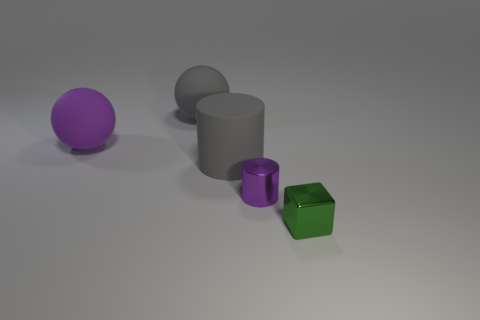Does the gray ball have the same material as the tiny thing that is right of the purple metallic object?
Keep it short and to the point. No. There is a cube that is the same material as the small purple thing; what is its size?
Offer a terse response. Small. Is there a large gray matte thing of the same shape as the tiny purple thing?
Your response must be concise. Yes. How many objects are either things that are to the right of the purple shiny thing or big purple things?
Your answer should be compact. 2. There is a matte sphere that is the same color as the large cylinder; what is its size?
Your answer should be very brief. Large. Does the ball in front of the gray ball have the same color as the tiny object that is left of the tiny green metallic block?
Your response must be concise. Yes. How big is the matte cylinder?
Offer a terse response. Large. How many tiny objects are either blocks or metallic objects?
Your response must be concise. 2. There is a cube that is the same size as the purple cylinder; what is its color?
Give a very brief answer. Green. How many other things are there of the same shape as the green object?
Ensure brevity in your answer.  0. 